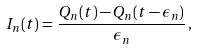<formula> <loc_0><loc_0><loc_500><loc_500>I _ { n } ( t ) = \, \frac { Q _ { n } ( t ) - Q _ { n } ( t - \epsilon _ { n } ) } { \epsilon _ { n } } \, ,</formula> 